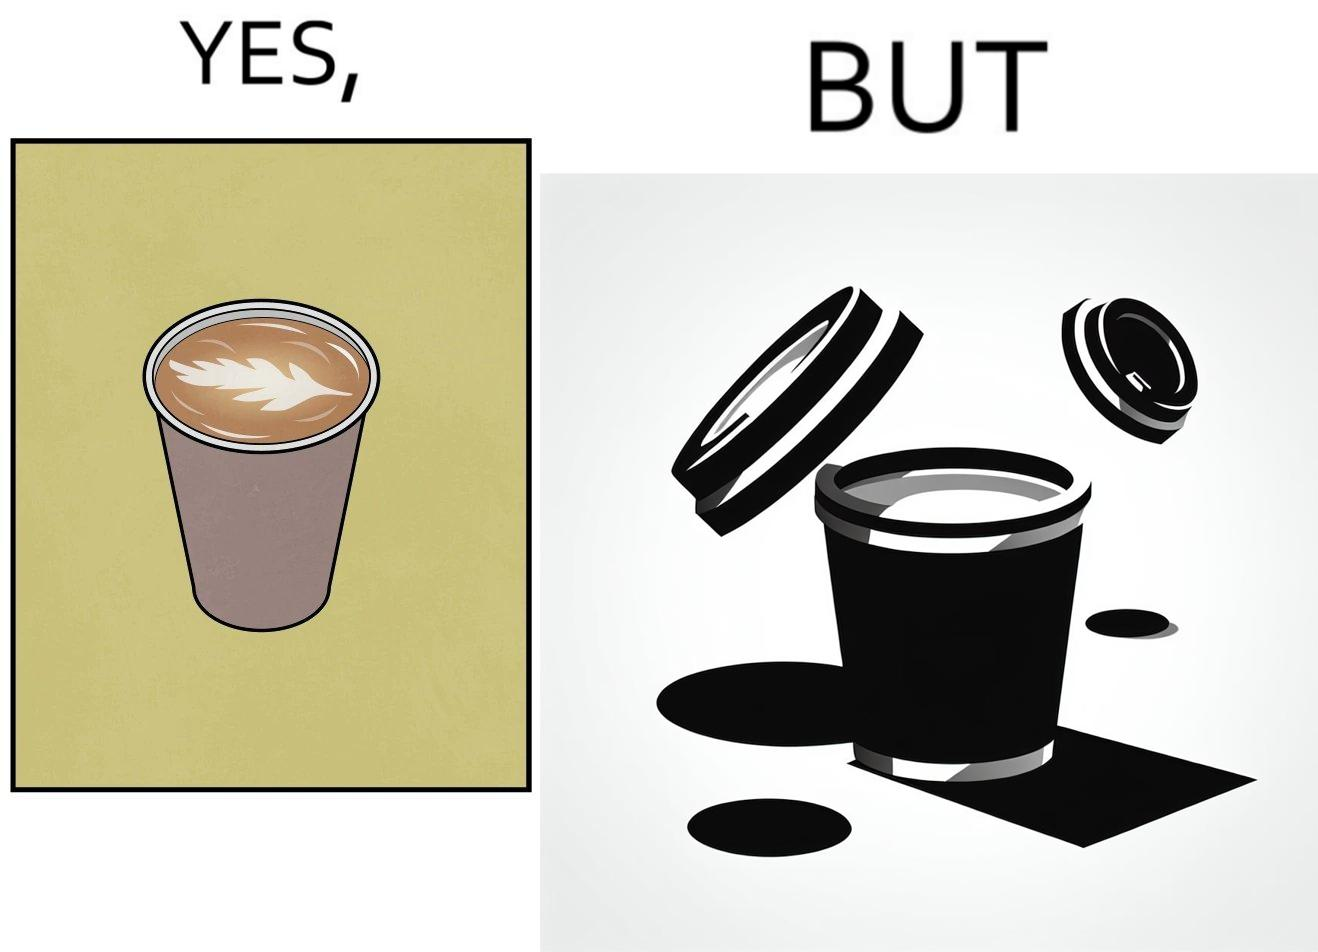Describe the satirical element in this image. The images are funny since it shows how someone has put effort into a cup of coffee to do latte art on it only for it to be invisible after a lid is put on the coffee cup before serving to a customer 